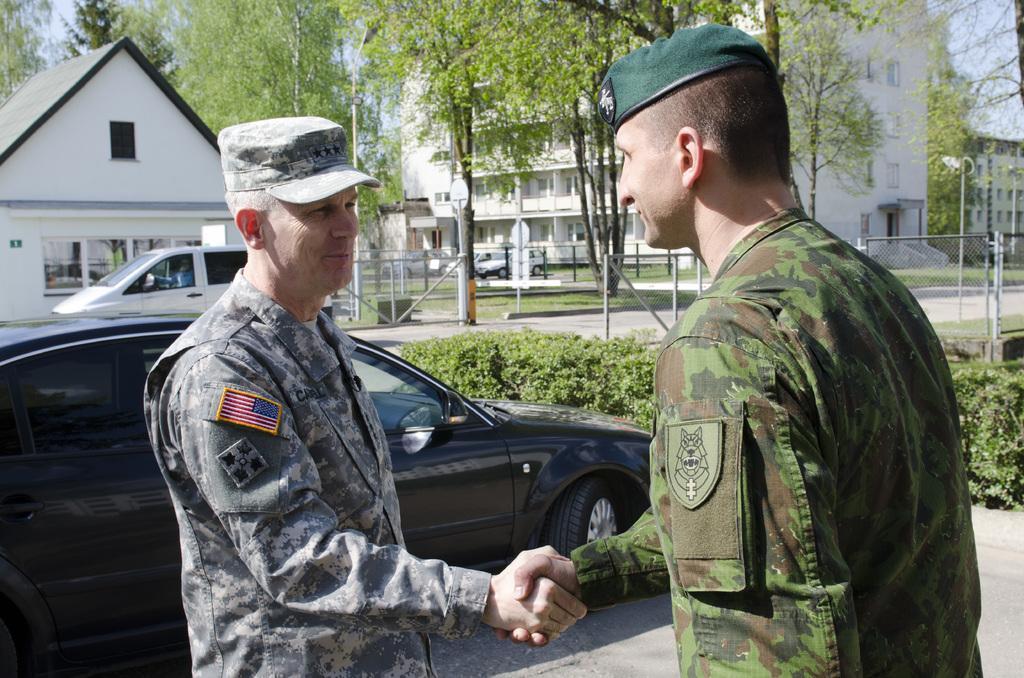Can you describe this image briefly? In this image we can see two people shaking their hands. We can also see some cars on the ground. On the backside we can see some plants, a fence, trees, street poles, buildings with windows, a house with a roof and the sky. 